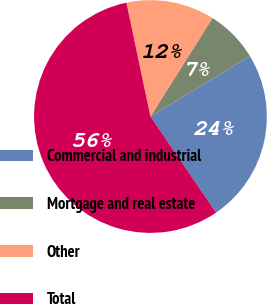Convert chart. <chart><loc_0><loc_0><loc_500><loc_500><pie_chart><fcel>Commercial and industrial<fcel>Mortgage and real estate<fcel>Other<fcel>Total<nl><fcel>24.15%<fcel>7.37%<fcel>12.26%<fcel>56.22%<nl></chart> 